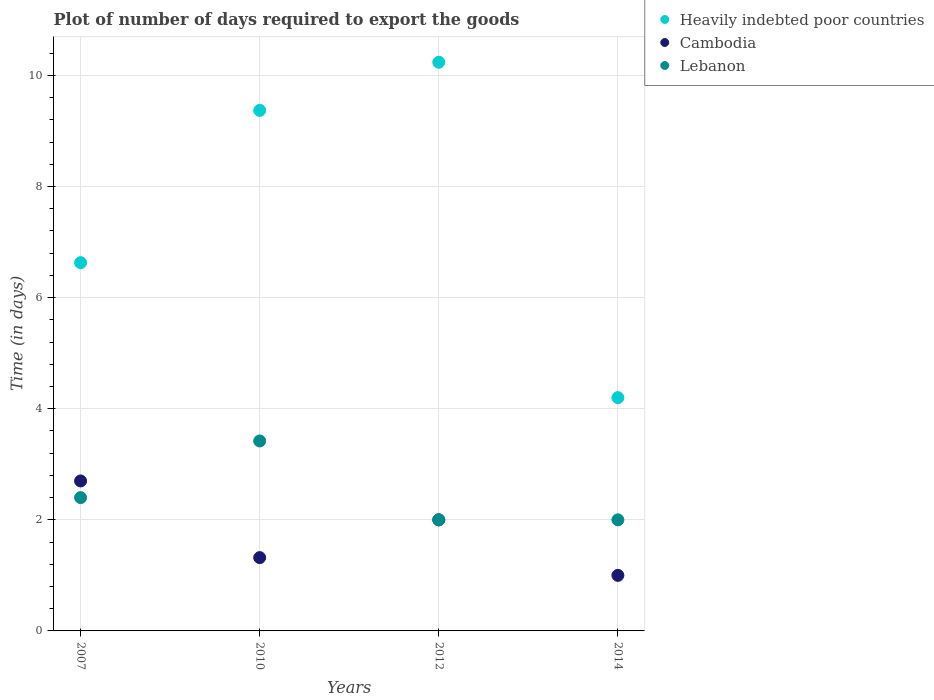How many different coloured dotlines are there?
Make the answer very short. 3. What is the time required to export goods in Heavily indebted poor countries in 2012?
Keep it short and to the point. 10.24. Across all years, what is the minimum time required to export goods in Heavily indebted poor countries?
Your response must be concise. 4.2. In which year was the time required to export goods in Heavily indebted poor countries minimum?
Offer a very short reply. 2014. What is the total time required to export goods in Lebanon in the graph?
Your answer should be compact. 9.82. What is the difference between the time required to export goods in Heavily indebted poor countries in 2007 and that in 2014?
Your answer should be compact. 2.43. What is the difference between the time required to export goods in Lebanon in 2014 and the time required to export goods in Cambodia in 2012?
Make the answer very short. 0. What is the average time required to export goods in Lebanon per year?
Offer a terse response. 2.46. What is the ratio of the time required to export goods in Heavily indebted poor countries in 2010 to that in 2014?
Your answer should be very brief. 2.23. What is the difference between the highest and the lowest time required to export goods in Heavily indebted poor countries?
Your response must be concise. 6.04. Is the sum of the time required to export goods in Lebanon in 2012 and 2014 greater than the maximum time required to export goods in Heavily indebted poor countries across all years?
Make the answer very short. No. Is it the case that in every year, the sum of the time required to export goods in Lebanon and time required to export goods in Heavily indebted poor countries  is greater than the time required to export goods in Cambodia?
Keep it short and to the point. Yes. Does the time required to export goods in Lebanon monotonically increase over the years?
Give a very brief answer. No. Is the time required to export goods in Lebanon strictly greater than the time required to export goods in Cambodia over the years?
Ensure brevity in your answer.  No. Is the time required to export goods in Heavily indebted poor countries strictly less than the time required to export goods in Lebanon over the years?
Make the answer very short. No. What is the difference between two consecutive major ticks on the Y-axis?
Offer a very short reply. 2. Does the graph contain any zero values?
Offer a terse response. No. Where does the legend appear in the graph?
Ensure brevity in your answer.  Top right. How many legend labels are there?
Make the answer very short. 3. What is the title of the graph?
Offer a terse response. Plot of number of days required to export the goods. What is the label or title of the X-axis?
Provide a short and direct response. Years. What is the label or title of the Y-axis?
Your response must be concise. Time (in days). What is the Time (in days) in Heavily indebted poor countries in 2007?
Keep it short and to the point. 6.63. What is the Time (in days) in Lebanon in 2007?
Offer a terse response. 2.4. What is the Time (in days) of Heavily indebted poor countries in 2010?
Your answer should be compact. 9.37. What is the Time (in days) in Cambodia in 2010?
Your response must be concise. 1.32. What is the Time (in days) of Lebanon in 2010?
Offer a terse response. 3.42. What is the Time (in days) in Heavily indebted poor countries in 2012?
Your answer should be compact. 10.24. What is the Time (in days) in Heavily indebted poor countries in 2014?
Provide a short and direct response. 4.2. What is the Time (in days) in Cambodia in 2014?
Provide a short and direct response. 1. What is the Time (in days) of Lebanon in 2014?
Provide a short and direct response. 2. Across all years, what is the maximum Time (in days) of Heavily indebted poor countries?
Provide a short and direct response. 10.24. Across all years, what is the maximum Time (in days) in Cambodia?
Offer a very short reply. 2.7. Across all years, what is the maximum Time (in days) of Lebanon?
Provide a short and direct response. 3.42. What is the total Time (in days) of Heavily indebted poor countries in the graph?
Provide a succinct answer. 30.44. What is the total Time (in days) in Cambodia in the graph?
Provide a succinct answer. 7.02. What is the total Time (in days) of Lebanon in the graph?
Give a very brief answer. 9.82. What is the difference between the Time (in days) of Heavily indebted poor countries in 2007 and that in 2010?
Ensure brevity in your answer.  -2.74. What is the difference between the Time (in days) in Cambodia in 2007 and that in 2010?
Offer a terse response. 1.38. What is the difference between the Time (in days) in Lebanon in 2007 and that in 2010?
Make the answer very short. -1.02. What is the difference between the Time (in days) of Heavily indebted poor countries in 2007 and that in 2012?
Ensure brevity in your answer.  -3.61. What is the difference between the Time (in days) of Cambodia in 2007 and that in 2012?
Provide a succinct answer. 0.7. What is the difference between the Time (in days) in Lebanon in 2007 and that in 2012?
Your response must be concise. 0.4. What is the difference between the Time (in days) of Heavily indebted poor countries in 2007 and that in 2014?
Your response must be concise. 2.43. What is the difference between the Time (in days) in Lebanon in 2007 and that in 2014?
Provide a short and direct response. 0.4. What is the difference between the Time (in days) in Heavily indebted poor countries in 2010 and that in 2012?
Your answer should be compact. -0.87. What is the difference between the Time (in days) in Cambodia in 2010 and that in 2012?
Provide a succinct answer. -0.68. What is the difference between the Time (in days) in Lebanon in 2010 and that in 2012?
Make the answer very short. 1.42. What is the difference between the Time (in days) of Heavily indebted poor countries in 2010 and that in 2014?
Provide a short and direct response. 5.17. What is the difference between the Time (in days) of Cambodia in 2010 and that in 2014?
Ensure brevity in your answer.  0.32. What is the difference between the Time (in days) of Lebanon in 2010 and that in 2014?
Provide a succinct answer. 1.42. What is the difference between the Time (in days) in Heavily indebted poor countries in 2012 and that in 2014?
Ensure brevity in your answer.  6.04. What is the difference between the Time (in days) of Heavily indebted poor countries in 2007 and the Time (in days) of Cambodia in 2010?
Offer a very short reply. 5.31. What is the difference between the Time (in days) in Heavily indebted poor countries in 2007 and the Time (in days) in Lebanon in 2010?
Provide a succinct answer. 3.21. What is the difference between the Time (in days) in Cambodia in 2007 and the Time (in days) in Lebanon in 2010?
Offer a terse response. -0.72. What is the difference between the Time (in days) in Heavily indebted poor countries in 2007 and the Time (in days) in Cambodia in 2012?
Your answer should be very brief. 4.63. What is the difference between the Time (in days) in Heavily indebted poor countries in 2007 and the Time (in days) in Lebanon in 2012?
Give a very brief answer. 4.63. What is the difference between the Time (in days) of Heavily indebted poor countries in 2007 and the Time (in days) of Cambodia in 2014?
Provide a succinct answer. 5.63. What is the difference between the Time (in days) of Heavily indebted poor countries in 2007 and the Time (in days) of Lebanon in 2014?
Provide a succinct answer. 4.63. What is the difference between the Time (in days) in Cambodia in 2007 and the Time (in days) in Lebanon in 2014?
Your answer should be compact. 0.7. What is the difference between the Time (in days) in Heavily indebted poor countries in 2010 and the Time (in days) in Cambodia in 2012?
Provide a short and direct response. 7.37. What is the difference between the Time (in days) of Heavily indebted poor countries in 2010 and the Time (in days) of Lebanon in 2012?
Give a very brief answer. 7.37. What is the difference between the Time (in days) of Cambodia in 2010 and the Time (in days) of Lebanon in 2012?
Your response must be concise. -0.68. What is the difference between the Time (in days) in Heavily indebted poor countries in 2010 and the Time (in days) in Cambodia in 2014?
Provide a succinct answer. 8.37. What is the difference between the Time (in days) of Heavily indebted poor countries in 2010 and the Time (in days) of Lebanon in 2014?
Keep it short and to the point. 7.37. What is the difference between the Time (in days) of Cambodia in 2010 and the Time (in days) of Lebanon in 2014?
Give a very brief answer. -0.68. What is the difference between the Time (in days) of Heavily indebted poor countries in 2012 and the Time (in days) of Cambodia in 2014?
Offer a terse response. 9.24. What is the difference between the Time (in days) in Heavily indebted poor countries in 2012 and the Time (in days) in Lebanon in 2014?
Ensure brevity in your answer.  8.24. What is the average Time (in days) of Heavily indebted poor countries per year?
Offer a terse response. 7.61. What is the average Time (in days) in Cambodia per year?
Provide a short and direct response. 1.75. What is the average Time (in days) of Lebanon per year?
Keep it short and to the point. 2.46. In the year 2007, what is the difference between the Time (in days) of Heavily indebted poor countries and Time (in days) of Cambodia?
Offer a very short reply. 3.93. In the year 2007, what is the difference between the Time (in days) in Heavily indebted poor countries and Time (in days) in Lebanon?
Provide a succinct answer. 4.23. In the year 2007, what is the difference between the Time (in days) in Cambodia and Time (in days) in Lebanon?
Your answer should be very brief. 0.3. In the year 2010, what is the difference between the Time (in days) in Heavily indebted poor countries and Time (in days) in Cambodia?
Offer a terse response. 8.05. In the year 2010, what is the difference between the Time (in days) in Heavily indebted poor countries and Time (in days) in Lebanon?
Your answer should be very brief. 5.95. In the year 2012, what is the difference between the Time (in days) of Heavily indebted poor countries and Time (in days) of Cambodia?
Make the answer very short. 8.24. In the year 2012, what is the difference between the Time (in days) in Heavily indebted poor countries and Time (in days) in Lebanon?
Provide a succinct answer. 8.24. In the year 2012, what is the difference between the Time (in days) in Cambodia and Time (in days) in Lebanon?
Make the answer very short. 0. In the year 2014, what is the difference between the Time (in days) in Cambodia and Time (in days) in Lebanon?
Your answer should be very brief. -1. What is the ratio of the Time (in days) in Heavily indebted poor countries in 2007 to that in 2010?
Keep it short and to the point. 0.71. What is the ratio of the Time (in days) of Cambodia in 2007 to that in 2010?
Provide a short and direct response. 2.05. What is the ratio of the Time (in days) of Lebanon in 2007 to that in 2010?
Ensure brevity in your answer.  0.7. What is the ratio of the Time (in days) in Heavily indebted poor countries in 2007 to that in 2012?
Make the answer very short. 0.65. What is the ratio of the Time (in days) in Cambodia in 2007 to that in 2012?
Provide a succinct answer. 1.35. What is the ratio of the Time (in days) in Lebanon in 2007 to that in 2012?
Offer a very short reply. 1.2. What is the ratio of the Time (in days) in Heavily indebted poor countries in 2007 to that in 2014?
Your answer should be compact. 1.58. What is the ratio of the Time (in days) in Lebanon in 2007 to that in 2014?
Offer a very short reply. 1.2. What is the ratio of the Time (in days) in Heavily indebted poor countries in 2010 to that in 2012?
Your answer should be compact. 0.92. What is the ratio of the Time (in days) in Cambodia in 2010 to that in 2012?
Your answer should be very brief. 0.66. What is the ratio of the Time (in days) in Lebanon in 2010 to that in 2012?
Provide a succinct answer. 1.71. What is the ratio of the Time (in days) in Heavily indebted poor countries in 2010 to that in 2014?
Make the answer very short. 2.23. What is the ratio of the Time (in days) of Cambodia in 2010 to that in 2014?
Give a very brief answer. 1.32. What is the ratio of the Time (in days) in Lebanon in 2010 to that in 2014?
Ensure brevity in your answer.  1.71. What is the ratio of the Time (in days) of Heavily indebted poor countries in 2012 to that in 2014?
Your answer should be very brief. 2.44. What is the ratio of the Time (in days) of Cambodia in 2012 to that in 2014?
Provide a short and direct response. 2. What is the difference between the highest and the second highest Time (in days) in Heavily indebted poor countries?
Ensure brevity in your answer.  0.87. What is the difference between the highest and the lowest Time (in days) in Heavily indebted poor countries?
Ensure brevity in your answer.  6.04. What is the difference between the highest and the lowest Time (in days) of Cambodia?
Your response must be concise. 1.7. What is the difference between the highest and the lowest Time (in days) in Lebanon?
Keep it short and to the point. 1.42. 